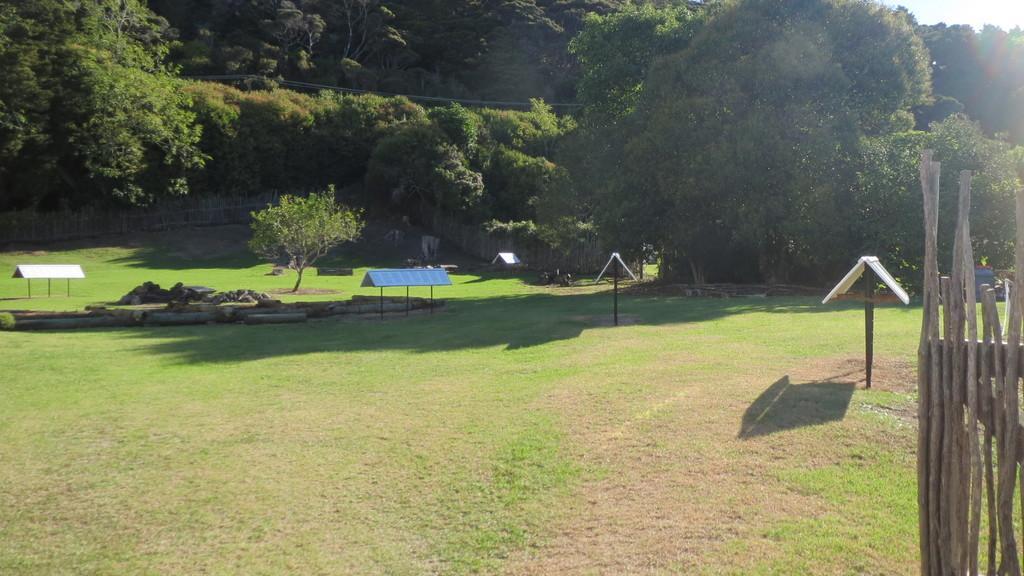In one or two sentences, can you explain what this image depicts? In this image, on the right side, we can see some sticks. On the right side, we can also see a hut and a pole. On the left side, we can see three poles and a metal roof. In the background, we can see a hut and a pole, trees, house, plants. At the top, we can see a sky, at the bottom, we can see a grass. 